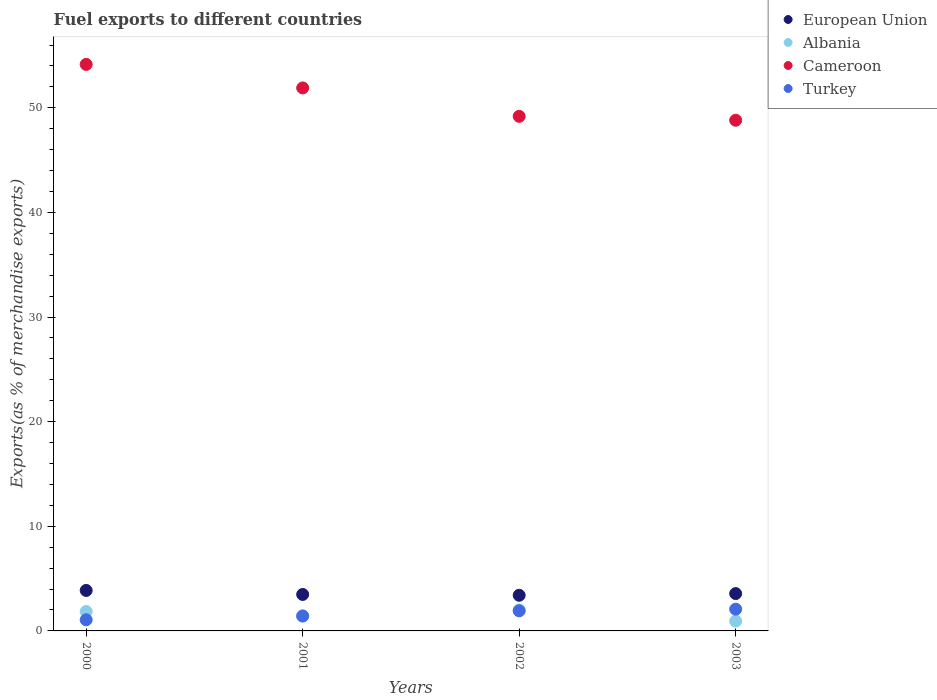Is the number of dotlines equal to the number of legend labels?
Offer a terse response. Yes. What is the percentage of exports to different countries in Albania in 2003?
Offer a very short reply. 0.94. Across all years, what is the maximum percentage of exports to different countries in European Union?
Give a very brief answer. 3.87. Across all years, what is the minimum percentage of exports to different countries in Albania?
Your answer should be compact. 0.94. What is the total percentage of exports to different countries in Cameroon in the graph?
Offer a terse response. 204.05. What is the difference between the percentage of exports to different countries in European Union in 2001 and that in 2002?
Your answer should be compact. 0.08. What is the difference between the percentage of exports to different countries in Cameroon in 2001 and the percentage of exports to different countries in Albania in 2000?
Provide a short and direct response. 50.05. What is the average percentage of exports to different countries in Turkey per year?
Make the answer very short. 1.62. In the year 2002, what is the difference between the percentage of exports to different countries in European Union and percentage of exports to different countries in Turkey?
Provide a short and direct response. 1.49. In how many years, is the percentage of exports to different countries in Cameroon greater than 14 %?
Offer a terse response. 4. What is the ratio of the percentage of exports to different countries in Turkey in 2000 to that in 2003?
Your answer should be compact. 0.51. Is the percentage of exports to different countries in Albania in 2000 less than that in 2002?
Ensure brevity in your answer.  Yes. Is the difference between the percentage of exports to different countries in European Union in 2000 and 2002 greater than the difference between the percentage of exports to different countries in Turkey in 2000 and 2002?
Your response must be concise. Yes. What is the difference between the highest and the second highest percentage of exports to different countries in European Union?
Make the answer very short. 0.3. What is the difference between the highest and the lowest percentage of exports to different countries in Albania?
Provide a succinct answer. 1.07. Is the sum of the percentage of exports to different countries in European Union in 2000 and 2001 greater than the maximum percentage of exports to different countries in Albania across all years?
Offer a very short reply. Yes. Is it the case that in every year, the sum of the percentage of exports to different countries in Albania and percentage of exports to different countries in Turkey  is greater than the sum of percentage of exports to different countries in European Union and percentage of exports to different countries in Cameroon?
Give a very brief answer. No. Is it the case that in every year, the sum of the percentage of exports to different countries in Albania and percentage of exports to different countries in European Union  is greater than the percentage of exports to different countries in Cameroon?
Keep it short and to the point. No. How many years are there in the graph?
Give a very brief answer. 4. What is the difference between two consecutive major ticks on the Y-axis?
Your answer should be compact. 10. Are the values on the major ticks of Y-axis written in scientific E-notation?
Your answer should be very brief. No. How many legend labels are there?
Your response must be concise. 4. How are the legend labels stacked?
Your response must be concise. Vertical. What is the title of the graph?
Ensure brevity in your answer.  Fuel exports to different countries. Does "Denmark" appear as one of the legend labels in the graph?
Make the answer very short. No. What is the label or title of the Y-axis?
Your answer should be very brief. Exports(as % of merchandise exports). What is the Exports(as % of merchandise exports) in European Union in 2000?
Your response must be concise. 3.87. What is the Exports(as % of merchandise exports) in Albania in 2000?
Ensure brevity in your answer.  1.85. What is the Exports(as % of merchandise exports) in Cameroon in 2000?
Offer a very short reply. 54.15. What is the Exports(as % of merchandise exports) of Turkey in 2000?
Your answer should be compact. 1.06. What is the Exports(as % of merchandise exports) in European Union in 2001?
Keep it short and to the point. 3.49. What is the Exports(as % of merchandise exports) in Albania in 2001?
Your answer should be compact. 1.45. What is the Exports(as % of merchandise exports) of Cameroon in 2001?
Ensure brevity in your answer.  51.9. What is the Exports(as % of merchandise exports) of Turkey in 2001?
Your answer should be compact. 1.42. What is the Exports(as % of merchandise exports) in European Union in 2002?
Make the answer very short. 3.41. What is the Exports(as % of merchandise exports) in Albania in 2002?
Give a very brief answer. 2.01. What is the Exports(as % of merchandise exports) in Cameroon in 2002?
Provide a short and direct response. 49.19. What is the Exports(as % of merchandise exports) in Turkey in 2002?
Ensure brevity in your answer.  1.92. What is the Exports(as % of merchandise exports) in European Union in 2003?
Your response must be concise. 3.57. What is the Exports(as % of merchandise exports) in Albania in 2003?
Your answer should be very brief. 0.94. What is the Exports(as % of merchandise exports) in Cameroon in 2003?
Make the answer very short. 48.81. What is the Exports(as % of merchandise exports) in Turkey in 2003?
Offer a terse response. 2.08. Across all years, what is the maximum Exports(as % of merchandise exports) of European Union?
Make the answer very short. 3.87. Across all years, what is the maximum Exports(as % of merchandise exports) of Albania?
Your answer should be compact. 2.01. Across all years, what is the maximum Exports(as % of merchandise exports) of Cameroon?
Offer a very short reply. 54.15. Across all years, what is the maximum Exports(as % of merchandise exports) in Turkey?
Your response must be concise. 2.08. Across all years, what is the minimum Exports(as % of merchandise exports) of European Union?
Offer a terse response. 3.41. Across all years, what is the minimum Exports(as % of merchandise exports) of Albania?
Ensure brevity in your answer.  0.94. Across all years, what is the minimum Exports(as % of merchandise exports) in Cameroon?
Provide a short and direct response. 48.81. Across all years, what is the minimum Exports(as % of merchandise exports) in Turkey?
Offer a terse response. 1.06. What is the total Exports(as % of merchandise exports) of European Union in the graph?
Keep it short and to the point. 14.33. What is the total Exports(as % of merchandise exports) in Albania in the graph?
Keep it short and to the point. 6.25. What is the total Exports(as % of merchandise exports) of Cameroon in the graph?
Give a very brief answer. 204.05. What is the total Exports(as % of merchandise exports) in Turkey in the graph?
Your answer should be very brief. 6.48. What is the difference between the Exports(as % of merchandise exports) in European Union in 2000 and that in 2001?
Offer a very short reply. 0.38. What is the difference between the Exports(as % of merchandise exports) of Albania in 2000 and that in 2001?
Keep it short and to the point. 0.4. What is the difference between the Exports(as % of merchandise exports) of Cameroon in 2000 and that in 2001?
Make the answer very short. 2.25. What is the difference between the Exports(as % of merchandise exports) in Turkey in 2000 and that in 2001?
Keep it short and to the point. -0.36. What is the difference between the Exports(as % of merchandise exports) in European Union in 2000 and that in 2002?
Your response must be concise. 0.46. What is the difference between the Exports(as % of merchandise exports) in Albania in 2000 and that in 2002?
Ensure brevity in your answer.  -0.16. What is the difference between the Exports(as % of merchandise exports) in Cameroon in 2000 and that in 2002?
Provide a succinct answer. 4.96. What is the difference between the Exports(as % of merchandise exports) of Turkey in 2000 and that in 2002?
Make the answer very short. -0.86. What is the difference between the Exports(as % of merchandise exports) in European Union in 2000 and that in 2003?
Give a very brief answer. 0.3. What is the difference between the Exports(as % of merchandise exports) of Albania in 2000 and that in 2003?
Offer a very short reply. 0.91. What is the difference between the Exports(as % of merchandise exports) in Cameroon in 2000 and that in 2003?
Your answer should be very brief. 5.34. What is the difference between the Exports(as % of merchandise exports) of Turkey in 2000 and that in 2003?
Offer a terse response. -1.02. What is the difference between the Exports(as % of merchandise exports) in European Union in 2001 and that in 2002?
Your answer should be compact. 0.08. What is the difference between the Exports(as % of merchandise exports) in Albania in 2001 and that in 2002?
Keep it short and to the point. -0.56. What is the difference between the Exports(as % of merchandise exports) in Cameroon in 2001 and that in 2002?
Your answer should be very brief. 2.72. What is the difference between the Exports(as % of merchandise exports) of Turkey in 2001 and that in 2002?
Offer a very short reply. -0.5. What is the difference between the Exports(as % of merchandise exports) of European Union in 2001 and that in 2003?
Provide a succinct answer. -0.08. What is the difference between the Exports(as % of merchandise exports) of Albania in 2001 and that in 2003?
Offer a terse response. 0.51. What is the difference between the Exports(as % of merchandise exports) in Cameroon in 2001 and that in 2003?
Your response must be concise. 3.09. What is the difference between the Exports(as % of merchandise exports) of Turkey in 2001 and that in 2003?
Offer a very short reply. -0.66. What is the difference between the Exports(as % of merchandise exports) in European Union in 2002 and that in 2003?
Your answer should be compact. -0.16. What is the difference between the Exports(as % of merchandise exports) of Albania in 2002 and that in 2003?
Give a very brief answer. 1.07. What is the difference between the Exports(as % of merchandise exports) of Cameroon in 2002 and that in 2003?
Offer a very short reply. 0.37. What is the difference between the Exports(as % of merchandise exports) of Turkey in 2002 and that in 2003?
Your answer should be compact. -0.16. What is the difference between the Exports(as % of merchandise exports) in European Union in 2000 and the Exports(as % of merchandise exports) in Albania in 2001?
Make the answer very short. 2.42. What is the difference between the Exports(as % of merchandise exports) in European Union in 2000 and the Exports(as % of merchandise exports) in Cameroon in 2001?
Your response must be concise. -48.03. What is the difference between the Exports(as % of merchandise exports) in European Union in 2000 and the Exports(as % of merchandise exports) in Turkey in 2001?
Your answer should be compact. 2.45. What is the difference between the Exports(as % of merchandise exports) of Albania in 2000 and the Exports(as % of merchandise exports) of Cameroon in 2001?
Offer a terse response. -50.05. What is the difference between the Exports(as % of merchandise exports) of Albania in 2000 and the Exports(as % of merchandise exports) of Turkey in 2001?
Your response must be concise. 0.43. What is the difference between the Exports(as % of merchandise exports) in Cameroon in 2000 and the Exports(as % of merchandise exports) in Turkey in 2001?
Keep it short and to the point. 52.73. What is the difference between the Exports(as % of merchandise exports) in European Union in 2000 and the Exports(as % of merchandise exports) in Albania in 2002?
Offer a terse response. 1.86. What is the difference between the Exports(as % of merchandise exports) in European Union in 2000 and the Exports(as % of merchandise exports) in Cameroon in 2002?
Your answer should be compact. -45.32. What is the difference between the Exports(as % of merchandise exports) in European Union in 2000 and the Exports(as % of merchandise exports) in Turkey in 2002?
Your answer should be very brief. 1.95. What is the difference between the Exports(as % of merchandise exports) of Albania in 2000 and the Exports(as % of merchandise exports) of Cameroon in 2002?
Make the answer very short. -47.34. What is the difference between the Exports(as % of merchandise exports) in Albania in 2000 and the Exports(as % of merchandise exports) in Turkey in 2002?
Provide a succinct answer. -0.07. What is the difference between the Exports(as % of merchandise exports) of Cameroon in 2000 and the Exports(as % of merchandise exports) of Turkey in 2002?
Keep it short and to the point. 52.23. What is the difference between the Exports(as % of merchandise exports) of European Union in 2000 and the Exports(as % of merchandise exports) of Albania in 2003?
Offer a very short reply. 2.93. What is the difference between the Exports(as % of merchandise exports) of European Union in 2000 and the Exports(as % of merchandise exports) of Cameroon in 2003?
Keep it short and to the point. -44.94. What is the difference between the Exports(as % of merchandise exports) in European Union in 2000 and the Exports(as % of merchandise exports) in Turkey in 2003?
Your response must be concise. 1.79. What is the difference between the Exports(as % of merchandise exports) in Albania in 2000 and the Exports(as % of merchandise exports) in Cameroon in 2003?
Provide a short and direct response. -46.96. What is the difference between the Exports(as % of merchandise exports) in Albania in 2000 and the Exports(as % of merchandise exports) in Turkey in 2003?
Your response must be concise. -0.23. What is the difference between the Exports(as % of merchandise exports) in Cameroon in 2000 and the Exports(as % of merchandise exports) in Turkey in 2003?
Offer a terse response. 52.07. What is the difference between the Exports(as % of merchandise exports) in European Union in 2001 and the Exports(as % of merchandise exports) in Albania in 2002?
Your answer should be very brief. 1.48. What is the difference between the Exports(as % of merchandise exports) of European Union in 2001 and the Exports(as % of merchandise exports) of Cameroon in 2002?
Give a very brief answer. -45.7. What is the difference between the Exports(as % of merchandise exports) of European Union in 2001 and the Exports(as % of merchandise exports) of Turkey in 2002?
Your answer should be compact. 1.56. What is the difference between the Exports(as % of merchandise exports) of Albania in 2001 and the Exports(as % of merchandise exports) of Cameroon in 2002?
Offer a terse response. -47.74. What is the difference between the Exports(as % of merchandise exports) of Albania in 2001 and the Exports(as % of merchandise exports) of Turkey in 2002?
Your answer should be very brief. -0.47. What is the difference between the Exports(as % of merchandise exports) of Cameroon in 2001 and the Exports(as % of merchandise exports) of Turkey in 2002?
Your answer should be compact. 49.98. What is the difference between the Exports(as % of merchandise exports) in European Union in 2001 and the Exports(as % of merchandise exports) in Albania in 2003?
Keep it short and to the point. 2.55. What is the difference between the Exports(as % of merchandise exports) of European Union in 2001 and the Exports(as % of merchandise exports) of Cameroon in 2003?
Ensure brevity in your answer.  -45.33. What is the difference between the Exports(as % of merchandise exports) in European Union in 2001 and the Exports(as % of merchandise exports) in Turkey in 2003?
Your answer should be very brief. 1.41. What is the difference between the Exports(as % of merchandise exports) in Albania in 2001 and the Exports(as % of merchandise exports) in Cameroon in 2003?
Make the answer very short. -47.36. What is the difference between the Exports(as % of merchandise exports) in Albania in 2001 and the Exports(as % of merchandise exports) in Turkey in 2003?
Keep it short and to the point. -0.63. What is the difference between the Exports(as % of merchandise exports) in Cameroon in 2001 and the Exports(as % of merchandise exports) in Turkey in 2003?
Make the answer very short. 49.82. What is the difference between the Exports(as % of merchandise exports) of European Union in 2002 and the Exports(as % of merchandise exports) of Albania in 2003?
Your answer should be compact. 2.47. What is the difference between the Exports(as % of merchandise exports) of European Union in 2002 and the Exports(as % of merchandise exports) of Cameroon in 2003?
Give a very brief answer. -45.41. What is the difference between the Exports(as % of merchandise exports) in European Union in 2002 and the Exports(as % of merchandise exports) in Turkey in 2003?
Ensure brevity in your answer.  1.33. What is the difference between the Exports(as % of merchandise exports) in Albania in 2002 and the Exports(as % of merchandise exports) in Cameroon in 2003?
Make the answer very short. -46.8. What is the difference between the Exports(as % of merchandise exports) in Albania in 2002 and the Exports(as % of merchandise exports) in Turkey in 2003?
Your answer should be compact. -0.07. What is the difference between the Exports(as % of merchandise exports) of Cameroon in 2002 and the Exports(as % of merchandise exports) of Turkey in 2003?
Your answer should be compact. 47.11. What is the average Exports(as % of merchandise exports) of European Union per year?
Ensure brevity in your answer.  3.58. What is the average Exports(as % of merchandise exports) in Albania per year?
Your answer should be compact. 1.56. What is the average Exports(as % of merchandise exports) in Cameroon per year?
Your answer should be compact. 51.01. What is the average Exports(as % of merchandise exports) of Turkey per year?
Offer a terse response. 1.62. In the year 2000, what is the difference between the Exports(as % of merchandise exports) of European Union and Exports(as % of merchandise exports) of Albania?
Give a very brief answer. 2.02. In the year 2000, what is the difference between the Exports(as % of merchandise exports) in European Union and Exports(as % of merchandise exports) in Cameroon?
Your answer should be compact. -50.28. In the year 2000, what is the difference between the Exports(as % of merchandise exports) of European Union and Exports(as % of merchandise exports) of Turkey?
Give a very brief answer. 2.81. In the year 2000, what is the difference between the Exports(as % of merchandise exports) in Albania and Exports(as % of merchandise exports) in Cameroon?
Offer a very short reply. -52.3. In the year 2000, what is the difference between the Exports(as % of merchandise exports) in Albania and Exports(as % of merchandise exports) in Turkey?
Your answer should be very brief. 0.79. In the year 2000, what is the difference between the Exports(as % of merchandise exports) of Cameroon and Exports(as % of merchandise exports) of Turkey?
Keep it short and to the point. 53.09. In the year 2001, what is the difference between the Exports(as % of merchandise exports) of European Union and Exports(as % of merchandise exports) of Albania?
Offer a very short reply. 2.04. In the year 2001, what is the difference between the Exports(as % of merchandise exports) of European Union and Exports(as % of merchandise exports) of Cameroon?
Provide a short and direct response. -48.42. In the year 2001, what is the difference between the Exports(as % of merchandise exports) in European Union and Exports(as % of merchandise exports) in Turkey?
Offer a very short reply. 2.07. In the year 2001, what is the difference between the Exports(as % of merchandise exports) in Albania and Exports(as % of merchandise exports) in Cameroon?
Your answer should be compact. -50.45. In the year 2001, what is the difference between the Exports(as % of merchandise exports) of Albania and Exports(as % of merchandise exports) of Turkey?
Offer a very short reply. 0.03. In the year 2001, what is the difference between the Exports(as % of merchandise exports) in Cameroon and Exports(as % of merchandise exports) in Turkey?
Give a very brief answer. 50.48. In the year 2002, what is the difference between the Exports(as % of merchandise exports) in European Union and Exports(as % of merchandise exports) in Albania?
Provide a short and direct response. 1.4. In the year 2002, what is the difference between the Exports(as % of merchandise exports) of European Union and Exports(as % of merchandise exports) of Cameroon?
Keep it short and to the point. -45.78. In the year 2002, what is the difference between the Exports(as % of merchandise exports) in European Union and Exports(as % of merchandise exports) in Turkey?
Your response must be concise. 1.49. In the year 2002, what is the difference between the Exports(as % of merchandise exports) of Albania and Exports(as % of merchandise exports) of Cameroon?
Make the answer very short. -47.18. In the year 2002, what is the difference between the Exports(as % of merchandise exports) in Albania and Exports(as % of merchandise exports) in Turkey?
Keep it short and to the point. 0.09. In the year 2002, what is the difference between the Exports(as % of merchandise exports) of Cameroon and Exports(as % of merchandise exports) of Turkey?
Provide a short and direct response. 47.27. In the year 2003, what is the difference between the Exports(as % of merchandise exports) of European Union and Exports(as % of merchandise exports) of Albania?
Ensure brevity in your answer.  2.63. In the year 2003, what is the difference between the Exports(as % of merchandise exports) of European Union and Exports(as % of merchandise exports) of Cameroon?
Make the answer very short. -45.24. In the year 2003, what is the difference between the Exports(as % of merchandise exports) of European Union and Exports(as % of merchandise exports) of Turkey?
Provide a short and direct response. 1.49. In the year 2003, what is the difference between the Exports(as % of merchandise exports) in Albania and Exports(as % of merchandise exports) in Cameroon?
Your answer should be very brief. -47.87. In the year 2003, what is the difference between the Exports(as % of merchandise exports) in Albania and Exports(as % of merchandise exports) in Turkey?
Provide a short and direct response. -1.14. In the year 2003, what is the difference between the Exports(as % of merchandise exports) in Cameroon and Exports(as % of merchandise exports) in Turkey?
Offer a terse response. 46.73. What is the ratio of the Exports(as % of merchandise exports) of European Union in 2000 to that in 2001?
Your answer should be compact. 1.11. What is the ratio of the Exports(as % of merchandise exports) in Albania in 2000 to that in 2001?
Give a very brief answer. 1.28. What is the ratio of the Exports(as % of merchandise exports) in Cameroon in 2000 to that in 2001?
Your answer should be very brief. 1.04. What is the ratio of the Exports(as % of merchandise exports) of Turkey in 2000 to that in 2001?
Your answer should be very brief. 0.75. What is the ratio of the Exports(as % of merchandise exports) in European Union in 2000 to that in 2002?
Your answer should be very brief. 1.14. What is the ratio of the Exports(as % of merchandise exports) of Albania in 2000 to that in 2002?
Keep it short and to the point. 0.92. What is the ratio of the Exports(as % of merchandise exports) of Cameroon in 2000 to that in 2002?
Provide a short and direct response. 1.1. What is the ratio of the Exports(as % of merchandise exports) of Turkey in 2000 to that in 2002?
Give a very brief answer. 0.55. What is the ratio of the Exports(as % of merchandise exports) of European Union in 2000 to that in 2003?
Provide a short and direct response. 1.08. What is the ratio of the Exports(as % of merchandise exports) in Albania in 2000 to that in 2003?
Your answer should be very brief. 1.97. What is the ratio of the Exports(as % of merchandise exports) of Cameroon in 2000 to that in 2003?
Your response must be concise. 1.11. What is the ratio of the Exports(as % of merchandise exports) of Turkey in 2000 to that in 2003?
Offer a very short reply. 0.51. What is the ratio of the Exports(as % of merchandise exports) of European Union in 2001 to that in 2002?
Your answer should be compact. 1.02. What is the ratio of the Exports(as % of merchandise exports) of Albania in 2001 to that in 2002?
Offer a terse response. 0.72. What is the ratio of the Exports(as % of merchandise exports) of Cameroon in 2001 to that in 2002?
Your answer should be very brief. 1.06. What is the ratio of the Exports(as % of merchandise exports) in Turkey in 2001 to that in 2002?
Ensure brevity in your answer.  0.74. What is the ratio of the Exports(as % of merchandise exports) of European Union in 2001 to that in 2003?
Give a very brief answer. 0.98. What is the ratio of the Exports(as % of merchandise exports) of Albania in 2001 to that in 2003?
Your answer should be very brief. 1.54. What is the ratio of the Exports(as % of merchandise exports) in Cameroon in 2001 to that in 2003?
Offer a terse response. 1.06. What is the ratio of the Exports(as % of merchandise exports) of Turkey in 2001 to that in 2003?
Offer a very short reply. 0.68. What is the ratio of the Exports(as % of merchandise exports) of European Union in 2002 to that in 2003?
Provide a succinct answer. 0.95. What is the ratio of the Exports(as % of merchandise exports) of Albania in 2002 to that in 2003?
Your answer should be compact. 2.14. What is the ratio of the Exports(as % of merchandise exports) in Cameroon in 2002 to that in 2003?
Ensure brevity in your answer.  1.01. What is the ratio of the Exports(as % of merchandise exports) in Turkey in 2002 to that in 2003?
Your answer should be very brief. 0.92. What is the difference between the highest and the second highest Exports(as % of merchandise exports) of European Union?
Provide a short and direct response. 0.3. What is the difference between the highest and the second highest Exports(as % of merchandise exports) in Albania?
Give a very brief answer. 0.16. What is the difference between the highest and the second highest Exports(as % of merchandise exports) of Cameroon?
Ensure brevity in your answer.  2.25. What is the difference between the highest and the second highest Exports(as % of merchandise exports) of Turkey?
Provide a succinct answer. 0.16. What is the difference between the highest and the lowest Exports(as % of merchandise exports) in European Union?
Provide a succinct answer. 0.46. What is the difference between the highest and the lowest Exports(as % of merchandise exports) of Albania?
Ensure brevity in your answer.  1.07. What is the difference between the highest and the lowest Exports(as % of merchandise exports) in Cameroon?
Offer a terse response. 5.34. What is the difference between the highest and the lowest Exports(as % of merchandise exports) in Turkey?
Keep it short and to the point. 1.02. 